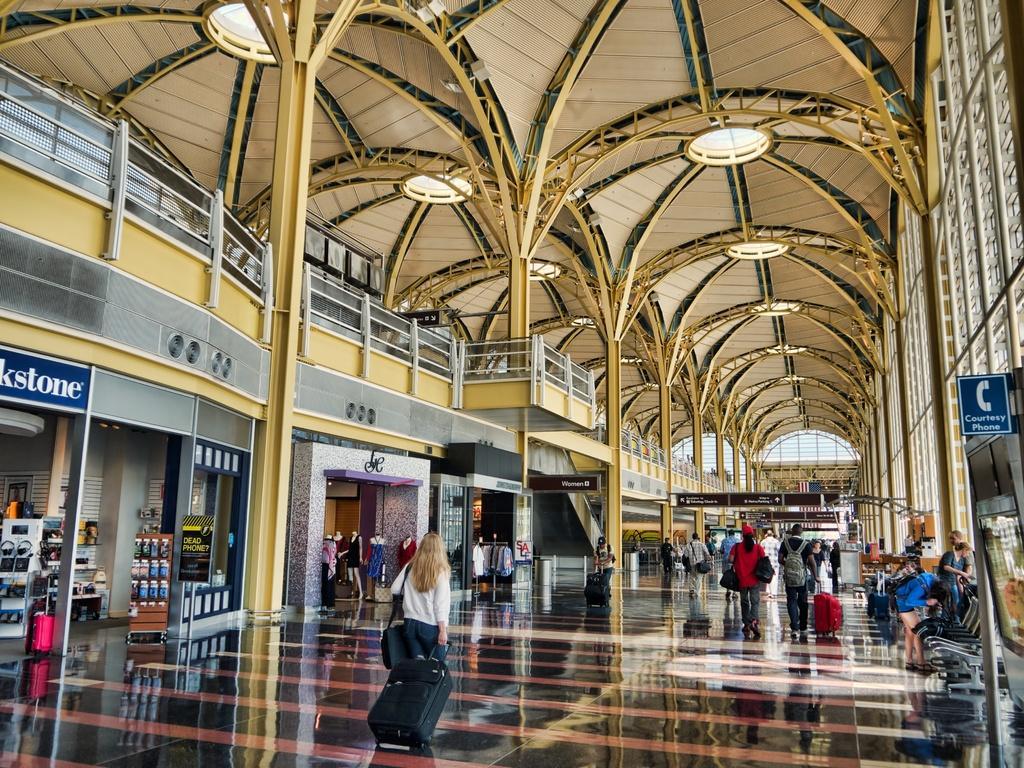Can you describe this image briefly? In this image we can see group of people wearing bags are standing on the floor, Some people are holding bags with their hands. On the left side of the image we can see some objects placed on racks, some clothes placed on mannequins and some shirts on hangers are placed on stands and a sign board with some text. On the right side of the image we can see some benches. In the background, we can see some railings and the roof. 